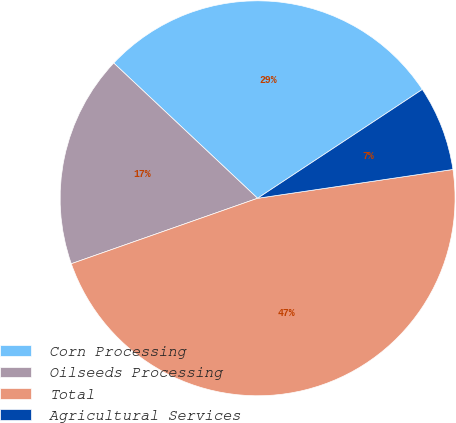<chart> <loc_0><loc_0><loc_500><loc_500><pie_chart><fcel>Corn Processing<fcel>Oilseeds Processing<fcel>Total<fcel>Agricultural Services<nl><fcel>28.7%<fcel>17.39%<fcel>46.96%<fcel>6.96%<nl></chart> 